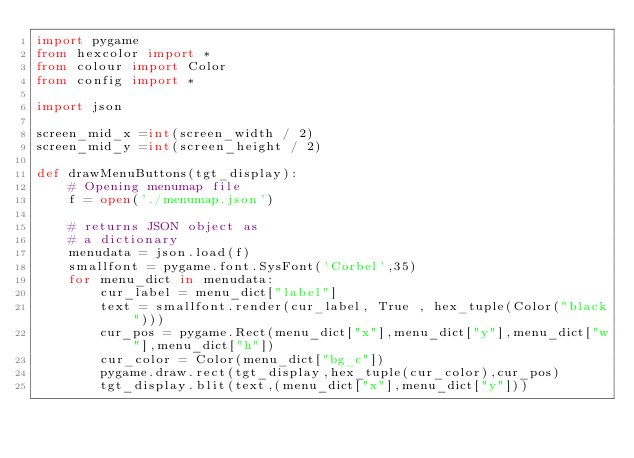<code> <loc_0><loc_0><loc_500><loc_500><_Python_>import pygame
from hexcolor import *
from colour import Color
from config import *

import json

screen_mid_x =int(screen_width / 2) 
screen_mid_y =int(screen_height / 2)

def drawMenuButtons(tgt_display):
	# Opening menumap file
	f = open('./menumap.json')

	# returns JSON object as
	# a dictionary
	menudata = json.load(f)
	smallfont = pygame.font.SysFont('Corbel',35)
	for menu_dict in menudata:
		cur_label = menu_dict["label"]
		text = smallfont.render(cur_label, True , hex_tuple(Color("black")))
		cur_pos = pygame.Rect(menu_dict["x"],menu_dict["y"],menu_dict["w"],menu_dict["h"])
		cur_color = Color(menu_dict["bg_c"])
		pygame.draw.rect(tgt_display,hex_tuple(cur_color),cur_pos)
		tgt_display.blit(text,(menu_dict["x"],menu_dict["y"]))</code> 